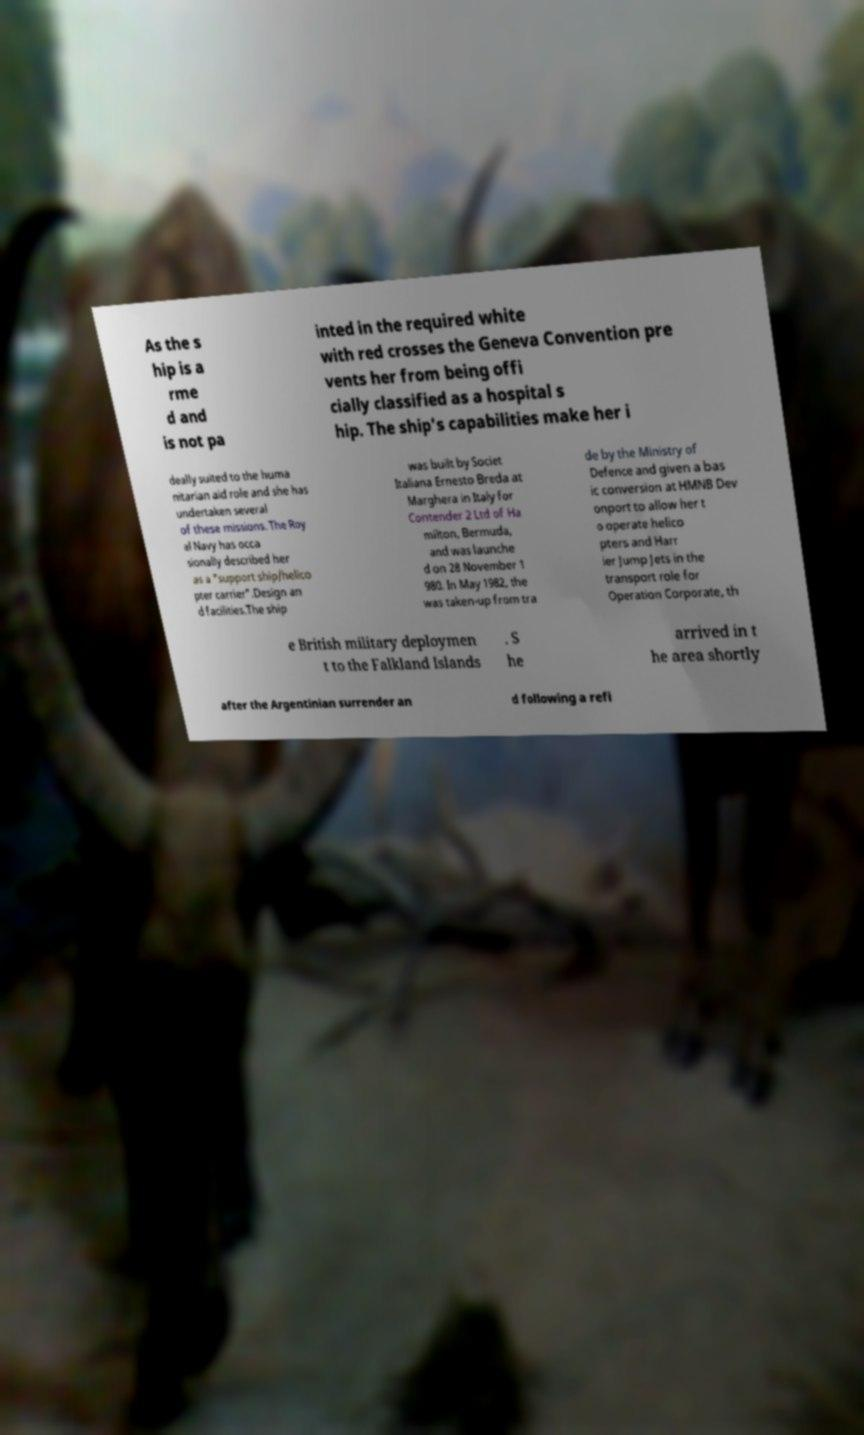Can you read and provide the text displayed in the image?This photo seems to have some interesting text. Can you extract and type it out for me? As the s hip is a rme d and is not pa inted in the required white with red crosses the Geneva Convention pre vents her from being offi cially classified as a hospital s hip. The ship's capabilities make her i deally suited to the huma nitarian aid role and she has undertaken several of these missions. The Roy al Navy has occa sionally described her as a "support ship/helico pter carrier".Design an d facilities.The ship was built by Societ Italiana Ernesto Breda at Marghera in Italy for Contender 2 Ltd of Ha milton, Bermuda, and was launche d on 28 November 1 980. In May 1982, the was taken-up from tra de by the Ministry of Defence and given a bas ic conversion at HMNB Dev onport to allow her t o operate helico pters and Harr ier Jump Jets in the transport role for Operation Corporate, th e British military deploymen t to the Falkland Islands . S he arrived in t he area shortly after the Argentinian surrender an d following a refi 